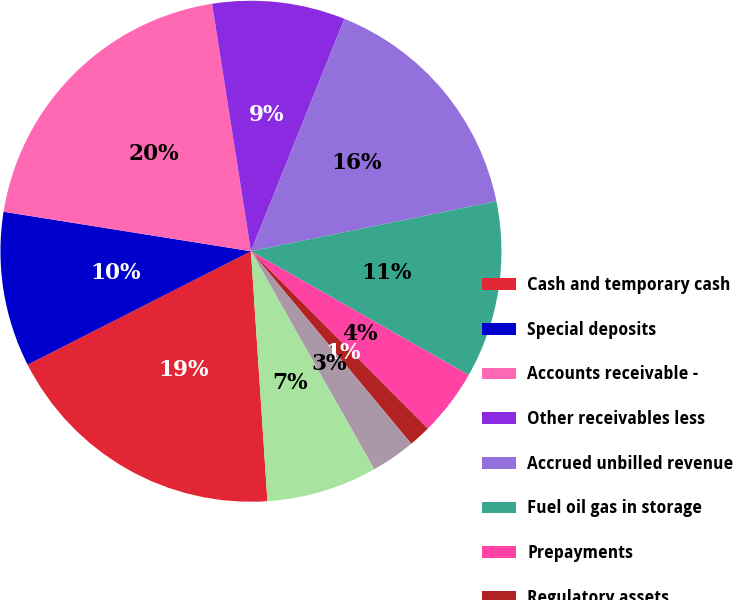Convert chart to OTSL. <chart><loc_0><loc_0><loc_500><loc_500><pie_chart><fcel>Cash and temporary cash<fcel>Special deposits<fcel>Accounts receivable -<fcel>Other receivables less<fcel>Accrued unbilled revenue<fcel>Fuel oil gas in storage<fcel>Prepayments<fcel>Regulatory assets<fcel>Deferred tax assets - current<fcel>Other current assets<nl><fcel>18.57%<fcel>10.0%<fcel>20.0%<fcel>8.57%<fcel>15.71%<fcel>11.43%<fcel>4.29%<fcel>1.43%<fcel>2.86%<fcel>7.14%<nl></chart> 